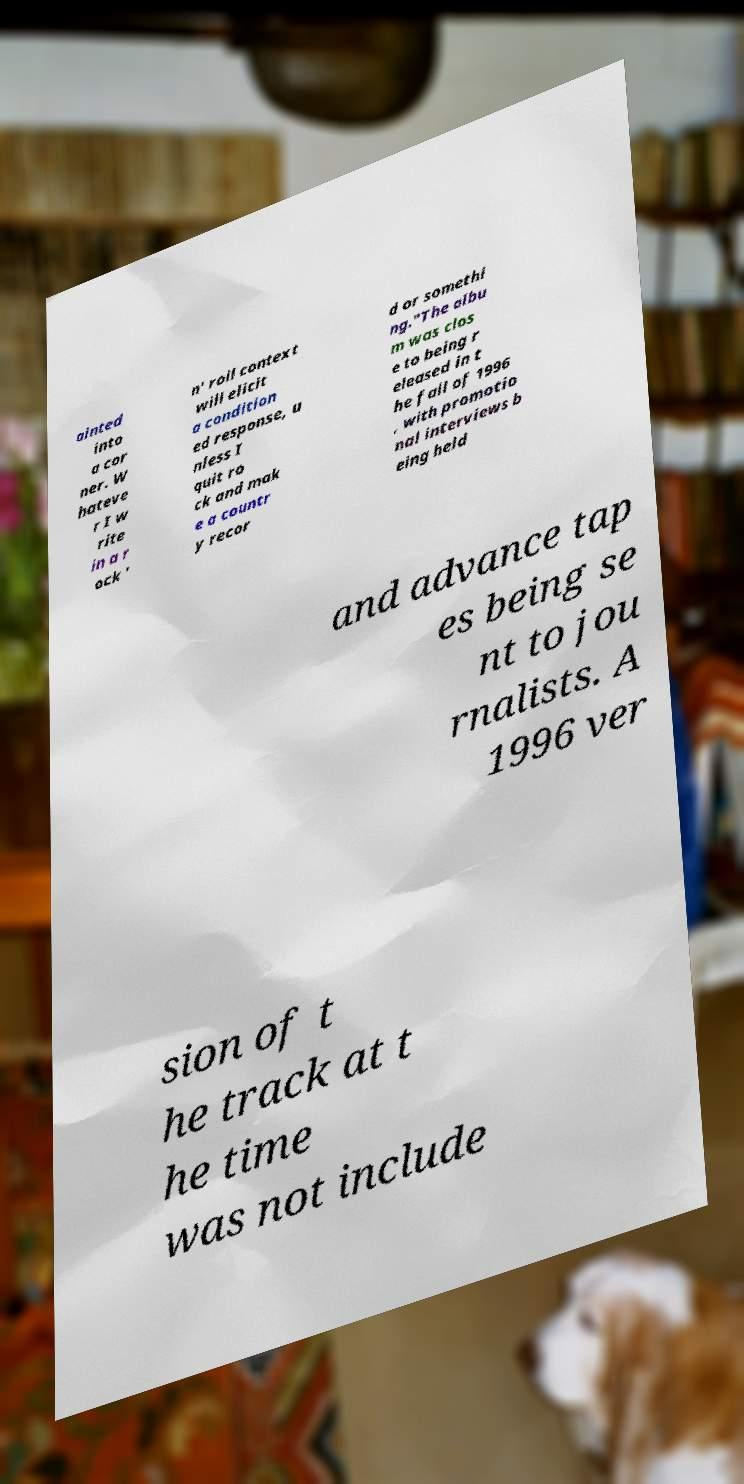Please read and relay the text visible in this image. What does it say? ainted into a cor ner. W hateve r I w rite in a r ock ' n' roll context will elicit a condition ed response, u nless I quit ro ck and mak e a countr y recor d or somethi ng."The albu m was clos e to being r eleased in t he fall of 1996 , with promotio nal interviews b eing held and advance tap es being se nt to jou rnalists. A 1996 ver sion of t he track at t he time was not include 